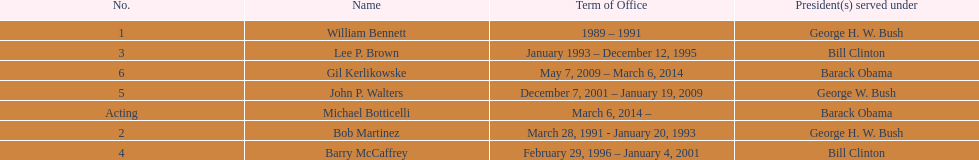What were the number of directors that stayed in office more than three years? 3. 